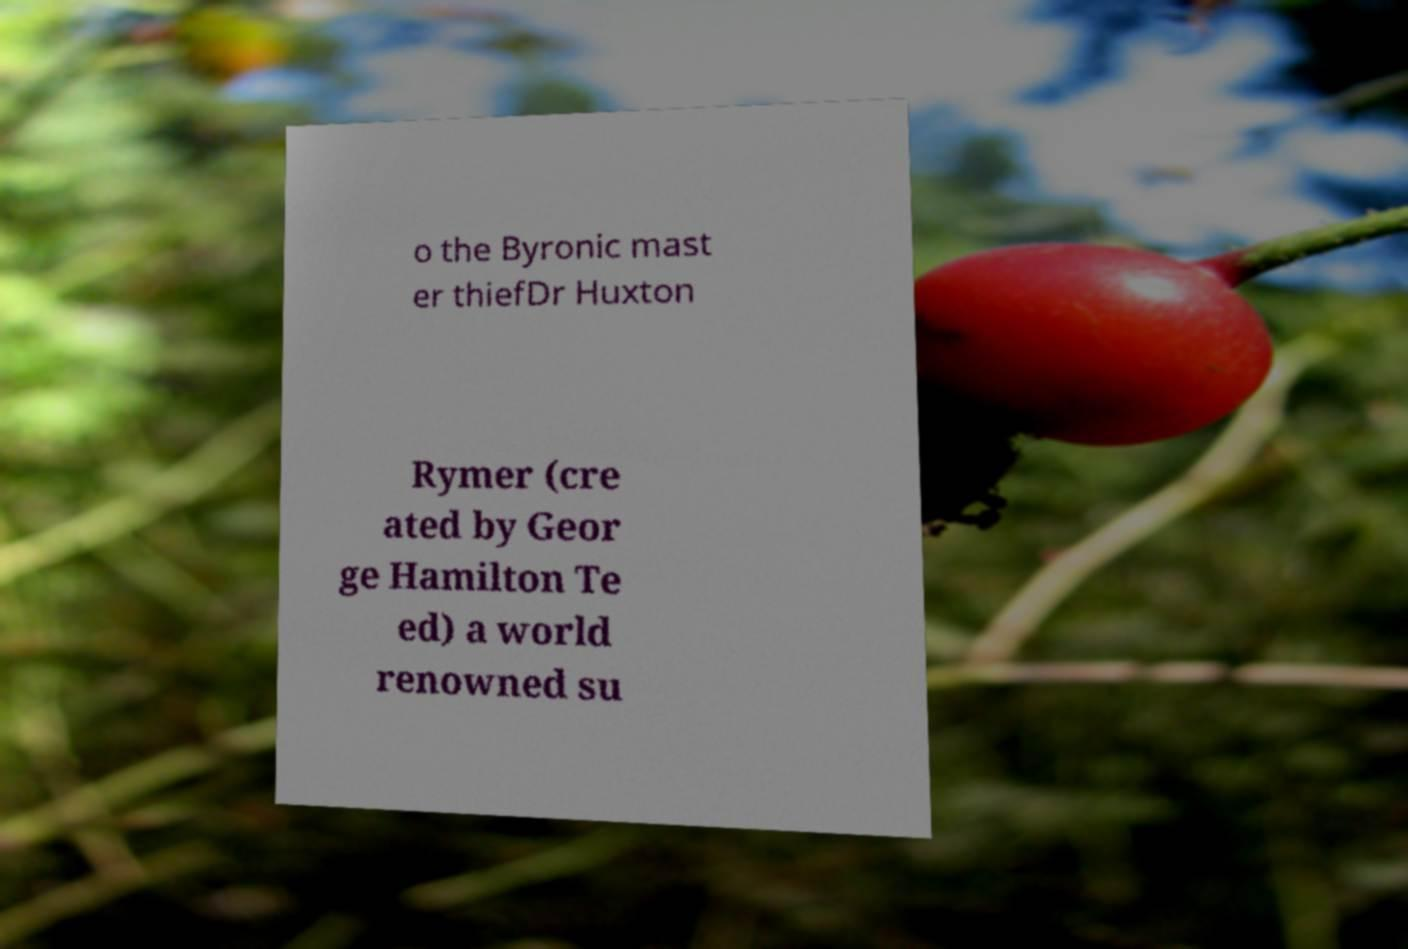Could you extract and type out the text from this image? o the Byronic mast er thiefDr Huxton Rymer (cre ated by Geor ge Hamilton Te ed) a world renowned su 